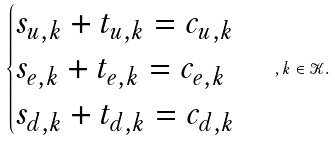Convert formula to latex. <formula><loc_0><loc_0><loc_500><loc_500>\begin{cases} s _ { u , k } + t _ { u , k } = c _ { u , k } \\ s _ { e , k } + t _ { e , k } = c _ { e , k } \\ s _ { d , k } + t _ { d , k } = c _ { d , k } \\ \end{cases} , k \in \mathcal { K } .</formula> 